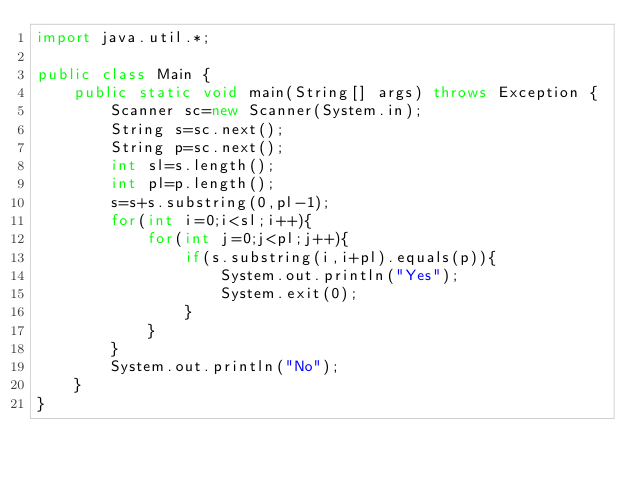Convert code to text. <code><loc_0><loc_0><loc_500><loc_500><_Java_>import java.util.*;

public class Main {
    public static void main(String[] args) throws Exception {
        Scanner sc=new Scanner(System.in);
        String s=sc.next();
        String p=sc.next();
        int sl=s.length();
        int pl=p.length();
        s=s+s.substring(0,pl-1);
        for(int i=0;i<sl;i++){
            for(int j=0;j<pl;j++){
                if(s.substring(i,i+pl).equals(p)){
                    System.out.println("Yes");
                    System.exit(0);
                }
            }
        }
        System.out.println("No");
    }
}

</code> 